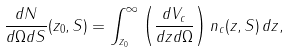Convert formula to latex. <formula><loc_0><loc_0><loc_500><loc_500>\frac { d N } { d \Omega d S } ( z _ { 0 } , S ) = \int ^ { \infty } _ { z _ { 0 } } \left ( \frac { d V _ { c } } { d z d \Omega } \right ) n _ { c } ( z , S ) \, d z ,</formula> 